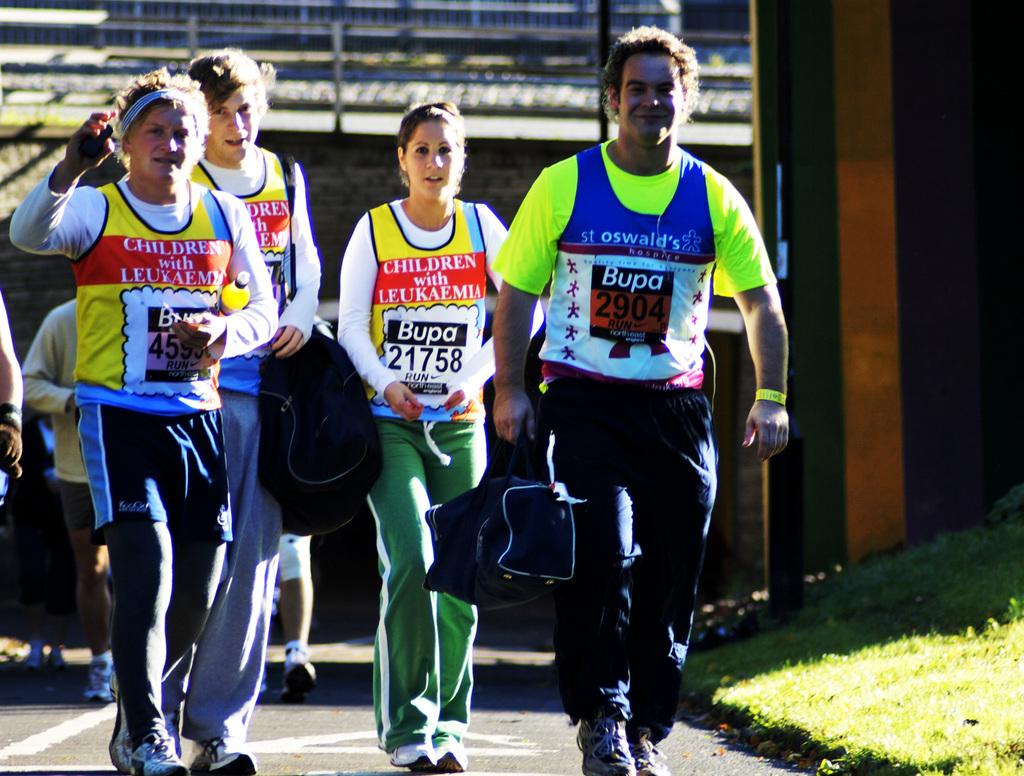What number is one of the runners associated with?
Ensure brevity in your answer.  21758. 